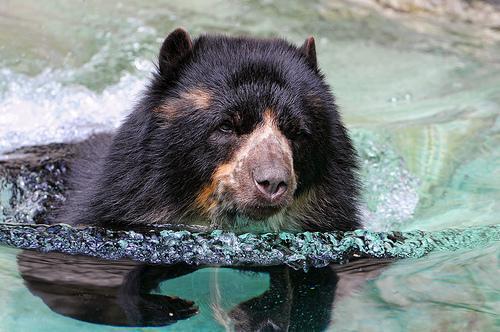How many bears are in the picture?
Give a very brief answer. 1. 